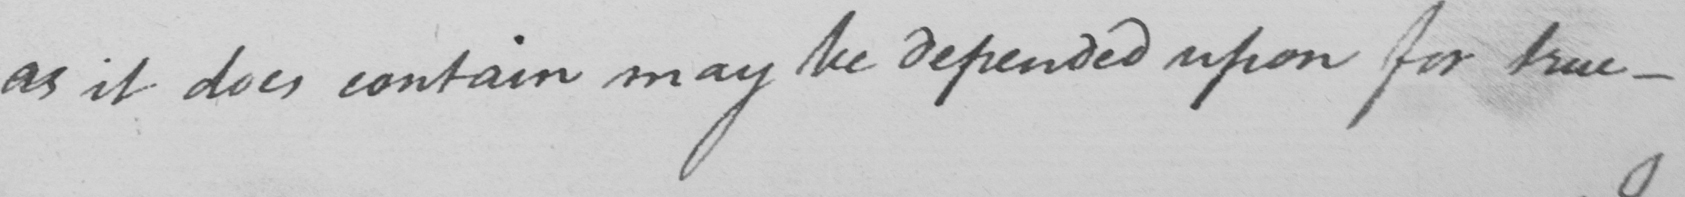What text is written in this handwritten line? as it does contain may be depended upon for true  _ 